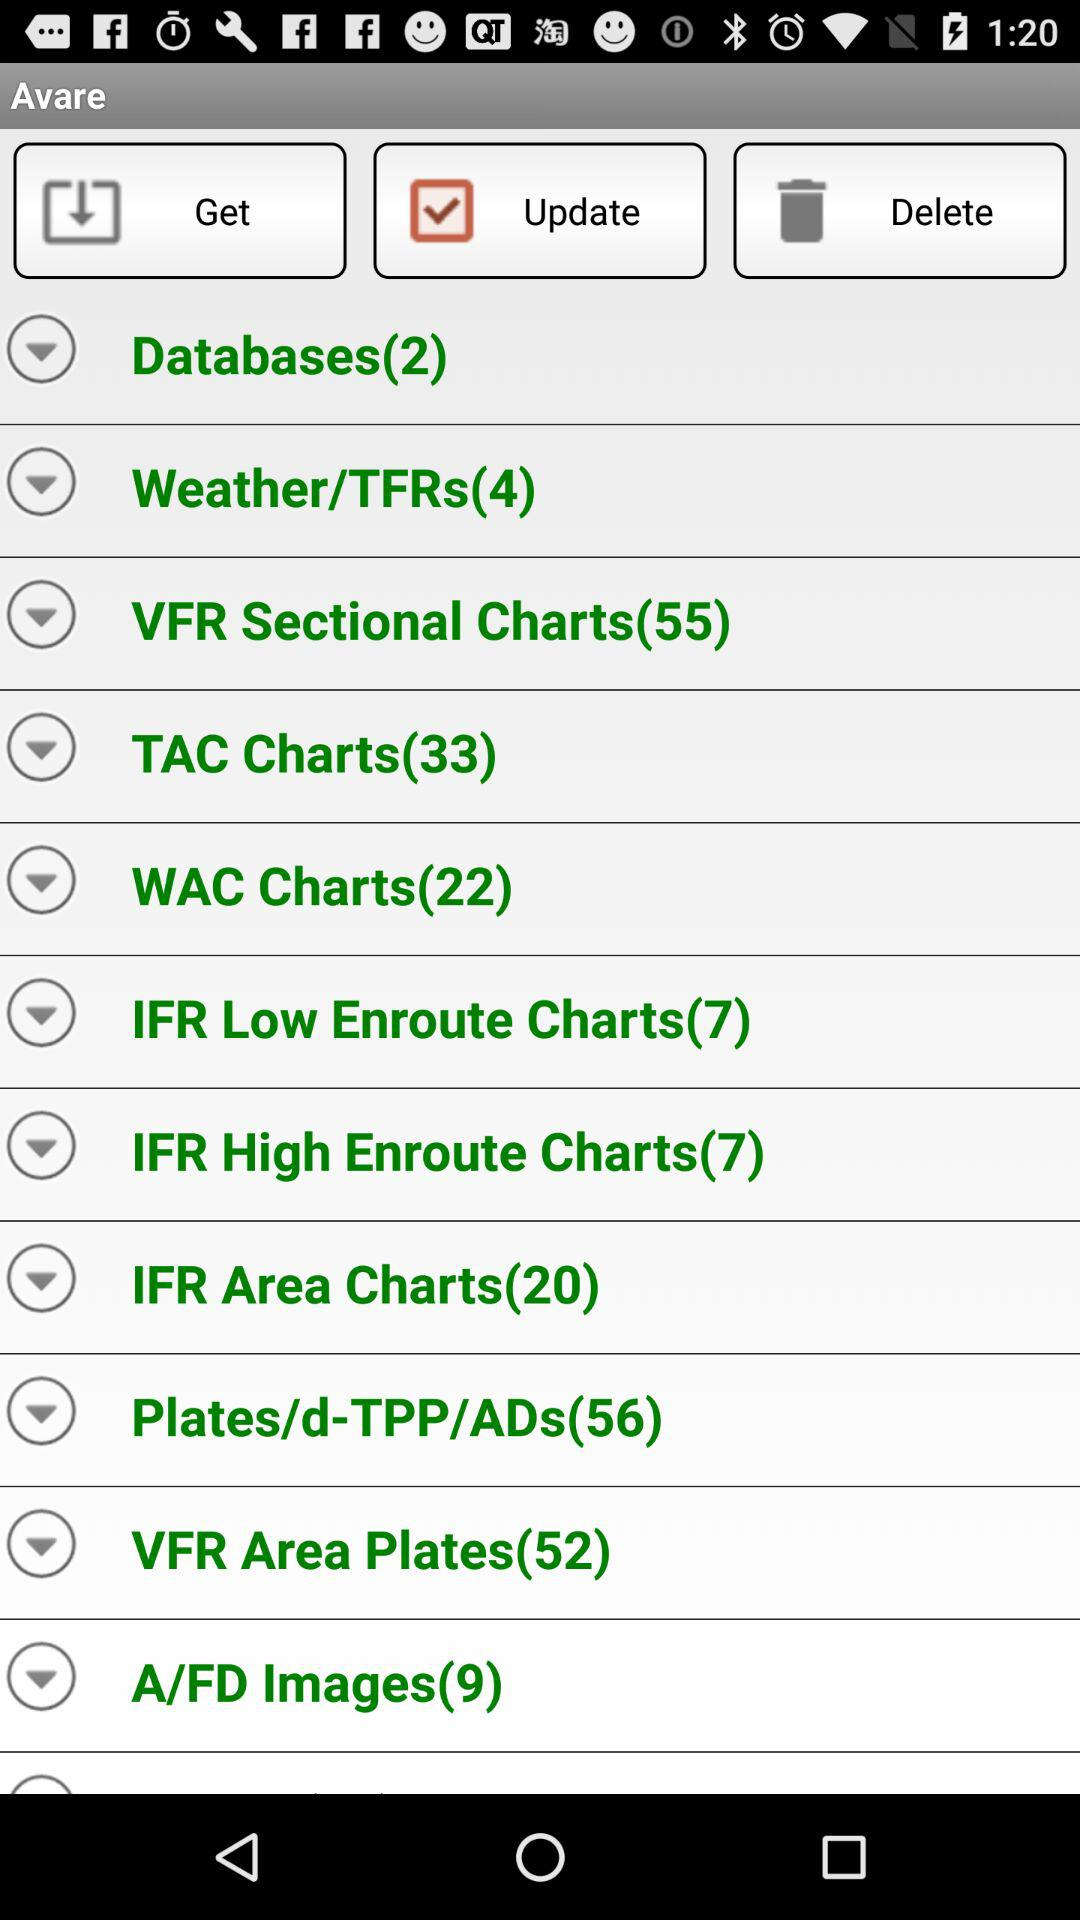How many databases are there?
When the provided information is insufficient, respond with <no answer>. <no answer> 